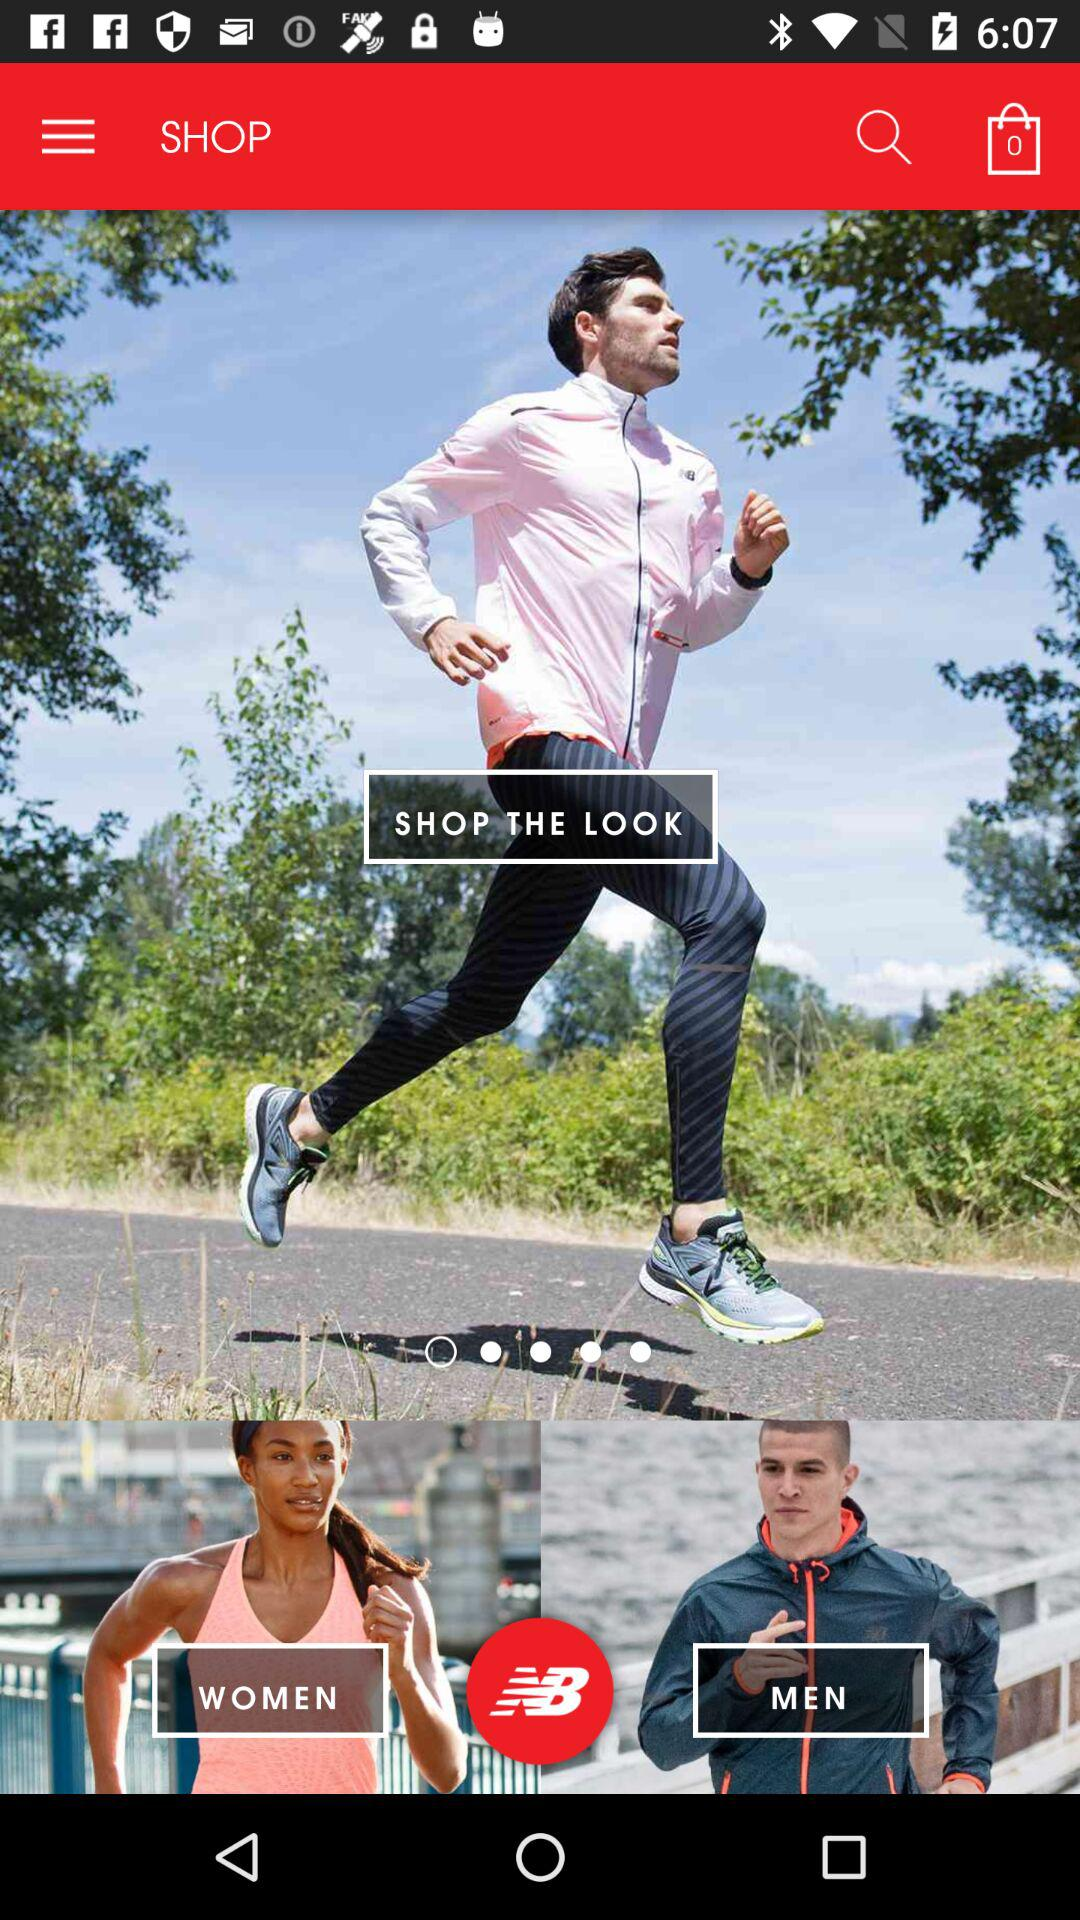How many items are in the bag? There are zero items in the bag. 